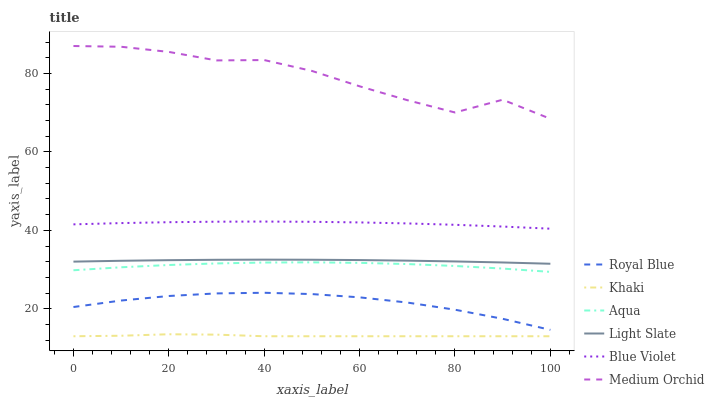Does Khaki have the minimum area under the curve?
Answer yes or no. Yes. Does Medium Orchid have the maximum area under the curve?
Answer yes or no. Yes. Does Light Slate have the minimum area under the curve?
Answer yes or no. No. Does Light Slate have the maximum area under the curve?
Answer yes or no. No. Is Light Slate the smoothest?
Answer yes or no. Yes. Is Medium Orchid the roughest?
Answer yes or no. Yes. Is Medium Orchid the smoothest?
Answer yes or no. No. Is Light Slate the roughest?
Answer yes or no. No. Does Light Slate have the lowest value?
Answer yes or no. No. Does Light Slate have the highest value?
Answer yes or no. No. Is Royal Blue less than Blue Violet?
Answer yes or no. Yes. Is Royal Blue greater than Khaki?
Answer yes or no. Yes. Does Royal Blue intersect Blue Violet?
Answer yes or no. No. 